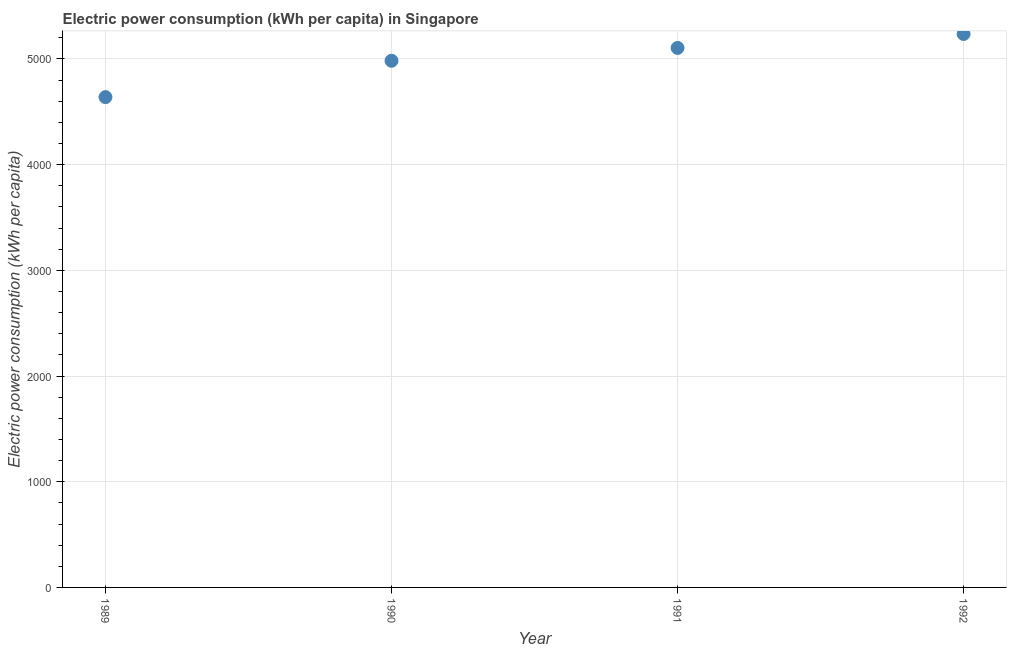What is the electric power consumption in 1992?
Your answer should be very brief. 5236.64. Across all years, what is the maximum electric power consumption?
Your answer should be compact. 5236.64. Across all years, what is the minimum electric power consumption?
Offer a terse response. 4639.19. What is the sum of the electric power consumption?
Ensure brevity in your answer.  2.00e+04. What is the difference between the electric power consumption in 1989 and 1990?
Give a very brief answer. -343.91. What is the average electric power consumption per year?
Offer a very short reply. 4990.93. What is the median electric power consumption?
Make the answer very short. 5043.94. In how many years, is the electric power consumption greater than 4000 kWh per capita?
Make the answer very short. 4. What is the ratio of the electric power consumption in 1991 to that in 1992?
Ensure brevity in your answer.  0.97. What is the difference between the highest and the second highest electric power consumption?
Make the answer very short. 131.85. What is the difference between the highest and the lowest electric power consumption?
Make the answer very short. 597.45. How many dotlines are there?
Provide a succinct answer. 1. Are the values on the major ticks of Y-axis written in scientific E-notation?
Your answer should be compact. No. Does the graph contain any zero values?
Offer a terse response. No. What is the title of the graph?
Your response must be concise. Electric power consumption (kWh per capita) in Singapore. What is the label or title of the Y-axis?
Keep it short and to the point. Electric power consumption (kWh per capita). What is the Electric power consumption (kWh per capita) in 1989?
Your answer should be compact. 4639.19. What is the Electric power consumption (kWh per capita) in 1990?
Give a very brief answer. 4983.1. What is the Electric power consumption (kWh per capita) in 1991?
Offer a terse response. 5104.78. What is the Electric power consumption (kWh per capita) in 1992?
Keep it short and to the point. 5236.64. What is the difference between the Electric power consumption (kWh per capita) in 1989 and 1990?
Offer a very short reply. -343.91. What is the difference between the Electric power consumption (kWh per capita) in 1989 and 1991?
Your response must be concise. -465.59. What is the difference between the Electric power consumption (kWh per capita) in 1989 and 1992?
Your answer should be compact. -597.45. What is the difference between the Electric power consumption (kWh per capita) in 1990 and 1991?
Give a very brief answer. -121.68. What is the difference between the Electric power consumption (kWh per capita) in 1990 and 1992?
Ensure brevity in your answer.  -253.54. What is the difference between the Electric power consumption (kWh per capita) in 1991 and 1992?
Offer a terse response. -131.85. What is the ratio of the Electric power consumption (kWh per capita) in 1989 to that in 1990?
Your response must be concise. 0.93. What is the ratio of the Electric power consumption (kWh per capita) in 1989 to that in 1991?
Keep it short and to the point. 0.91. What is the ratio of the Electric power consumption (kWh per capita) in 1989 to that in 1992?
Keep it short and to the point. 0.89. What is the ratio of the Electric power consumption (kWh per capita) in 1990 to that in 1992?
Provide a short and direct response. 0.95. 